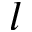Convert formula to latex. <formula><loc_0><loc_0><loc_500><loc_500>l</formula> 